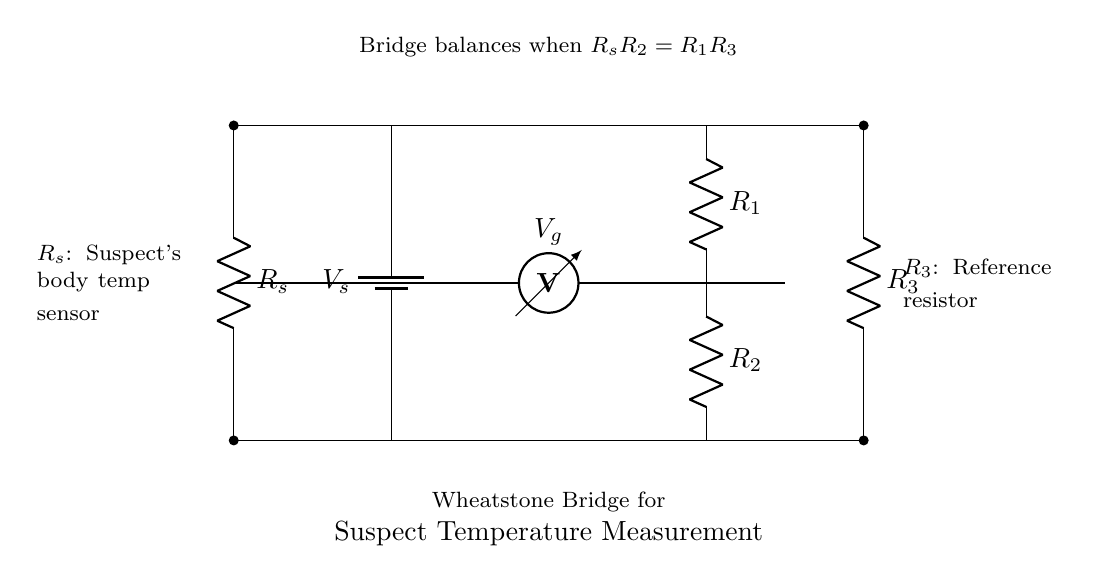What is the function of the battery in this circuit? The battery provides the necessary voltage supply for the Wheatstone bridge, allowing it to operate and measure the resistance of the suspect's body temperature sensor.
Answer: Voltage supply What is represented by the resistor labeled as "R_s"? "R_s" represents the resistance of the suspect's body temperature sensor, which is critical for this measurement system.
Answer: Suspect's body temperature sensor How many resistors are in the Wheatstone bridge? There are four resistors in the Wheatstone bridge circuit, namely R_1, R_2, R_3, and R_s.
Answer: Four What condition will cause the bridge to balance? The bridge balances when the product of R_s and R_2 equals the product of R_1 and R_3, as indicated in the circuit diagram.
Answer: Rs R2 = R1 R3 What is the purpose of the voltmeter in this circuit? The voltmeter measures the voltage difference between the two nodes, which helps determine if the bridge is balanced based on the readings from the resistors.
Answer: Measure voltage difference Which resistor acts as the reference resistor in this Wheatstone bridge? "R_3" serves as the reference resistor in the Wheatstone bridge circuit setup.
Answer: R_3 What happens when the bridge is unbalanced? An unbalanced Wheatstone bridge will produce a non-zero voltage reading at the voltmeter, indicating a difference in resistance values among the resistors.
Answer: Non-zero voltage reading 